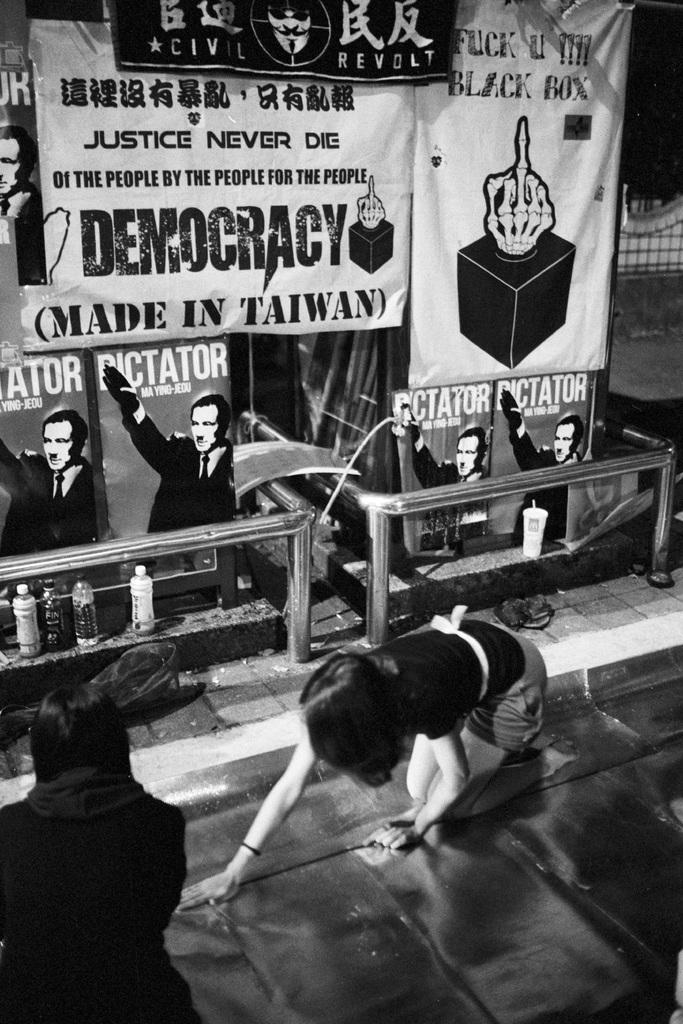How many women are present in the image? There are two women in the image. What are the women doing in the image? The women are on the floor. What can be seen in the background of the image? There are several posters in the background of the image. What objects are placed in the image? There are bottles placed in the image. What type of cars can be seen driving through the fire in the image? There are no cars or fire present in the image; it features two women on the floor with posters and bottles in the background. 